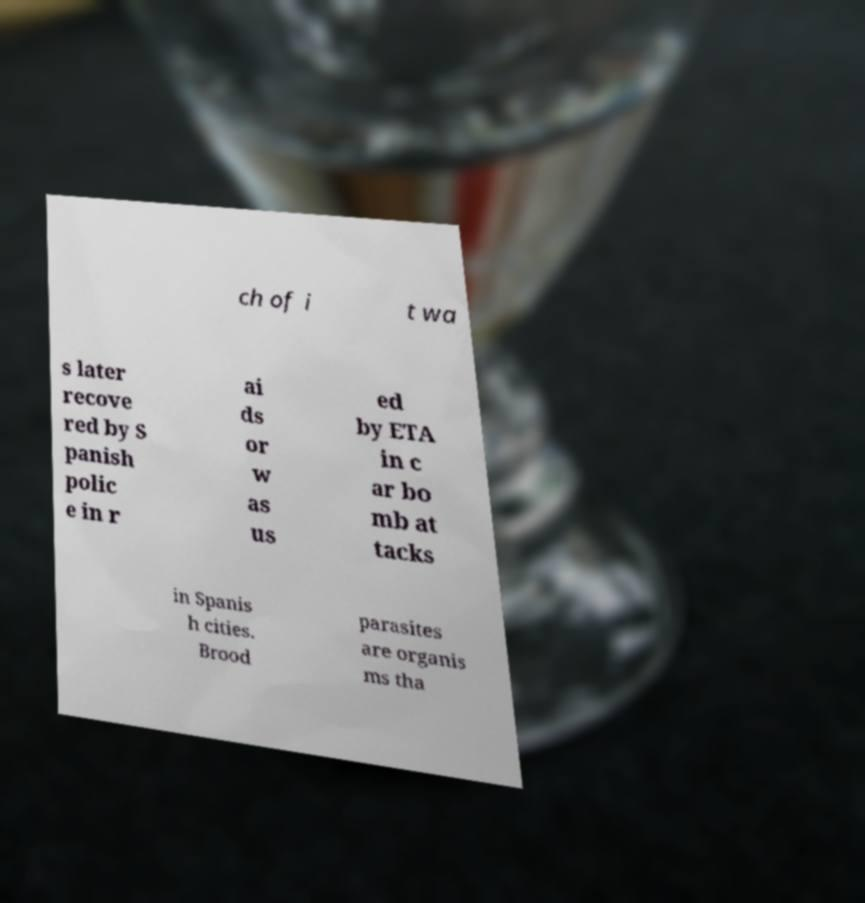I need the written content from this picture converted into text. Can you do that? ch of i t wa s later recove red by S panish polic e in r ai ds or w as us ed by ETA in c ar bo mb at tacks in Spanis h cities. Brood parasites are organis ms tha 